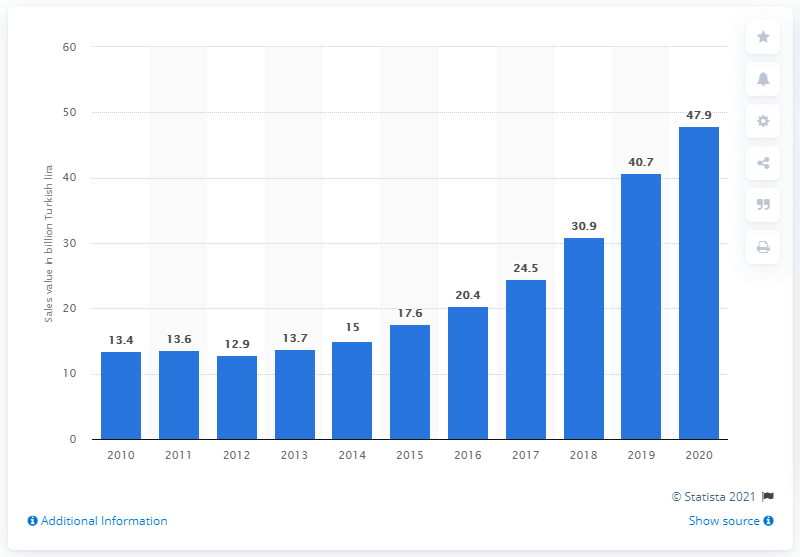Specify some key components in this picture. In 2020, the total sales value of the Turkish pharmaceutical market was 30.9 billion Turkish Liras. The Turkish pharmaceutical market experienced a significant increase in value in 2012. 